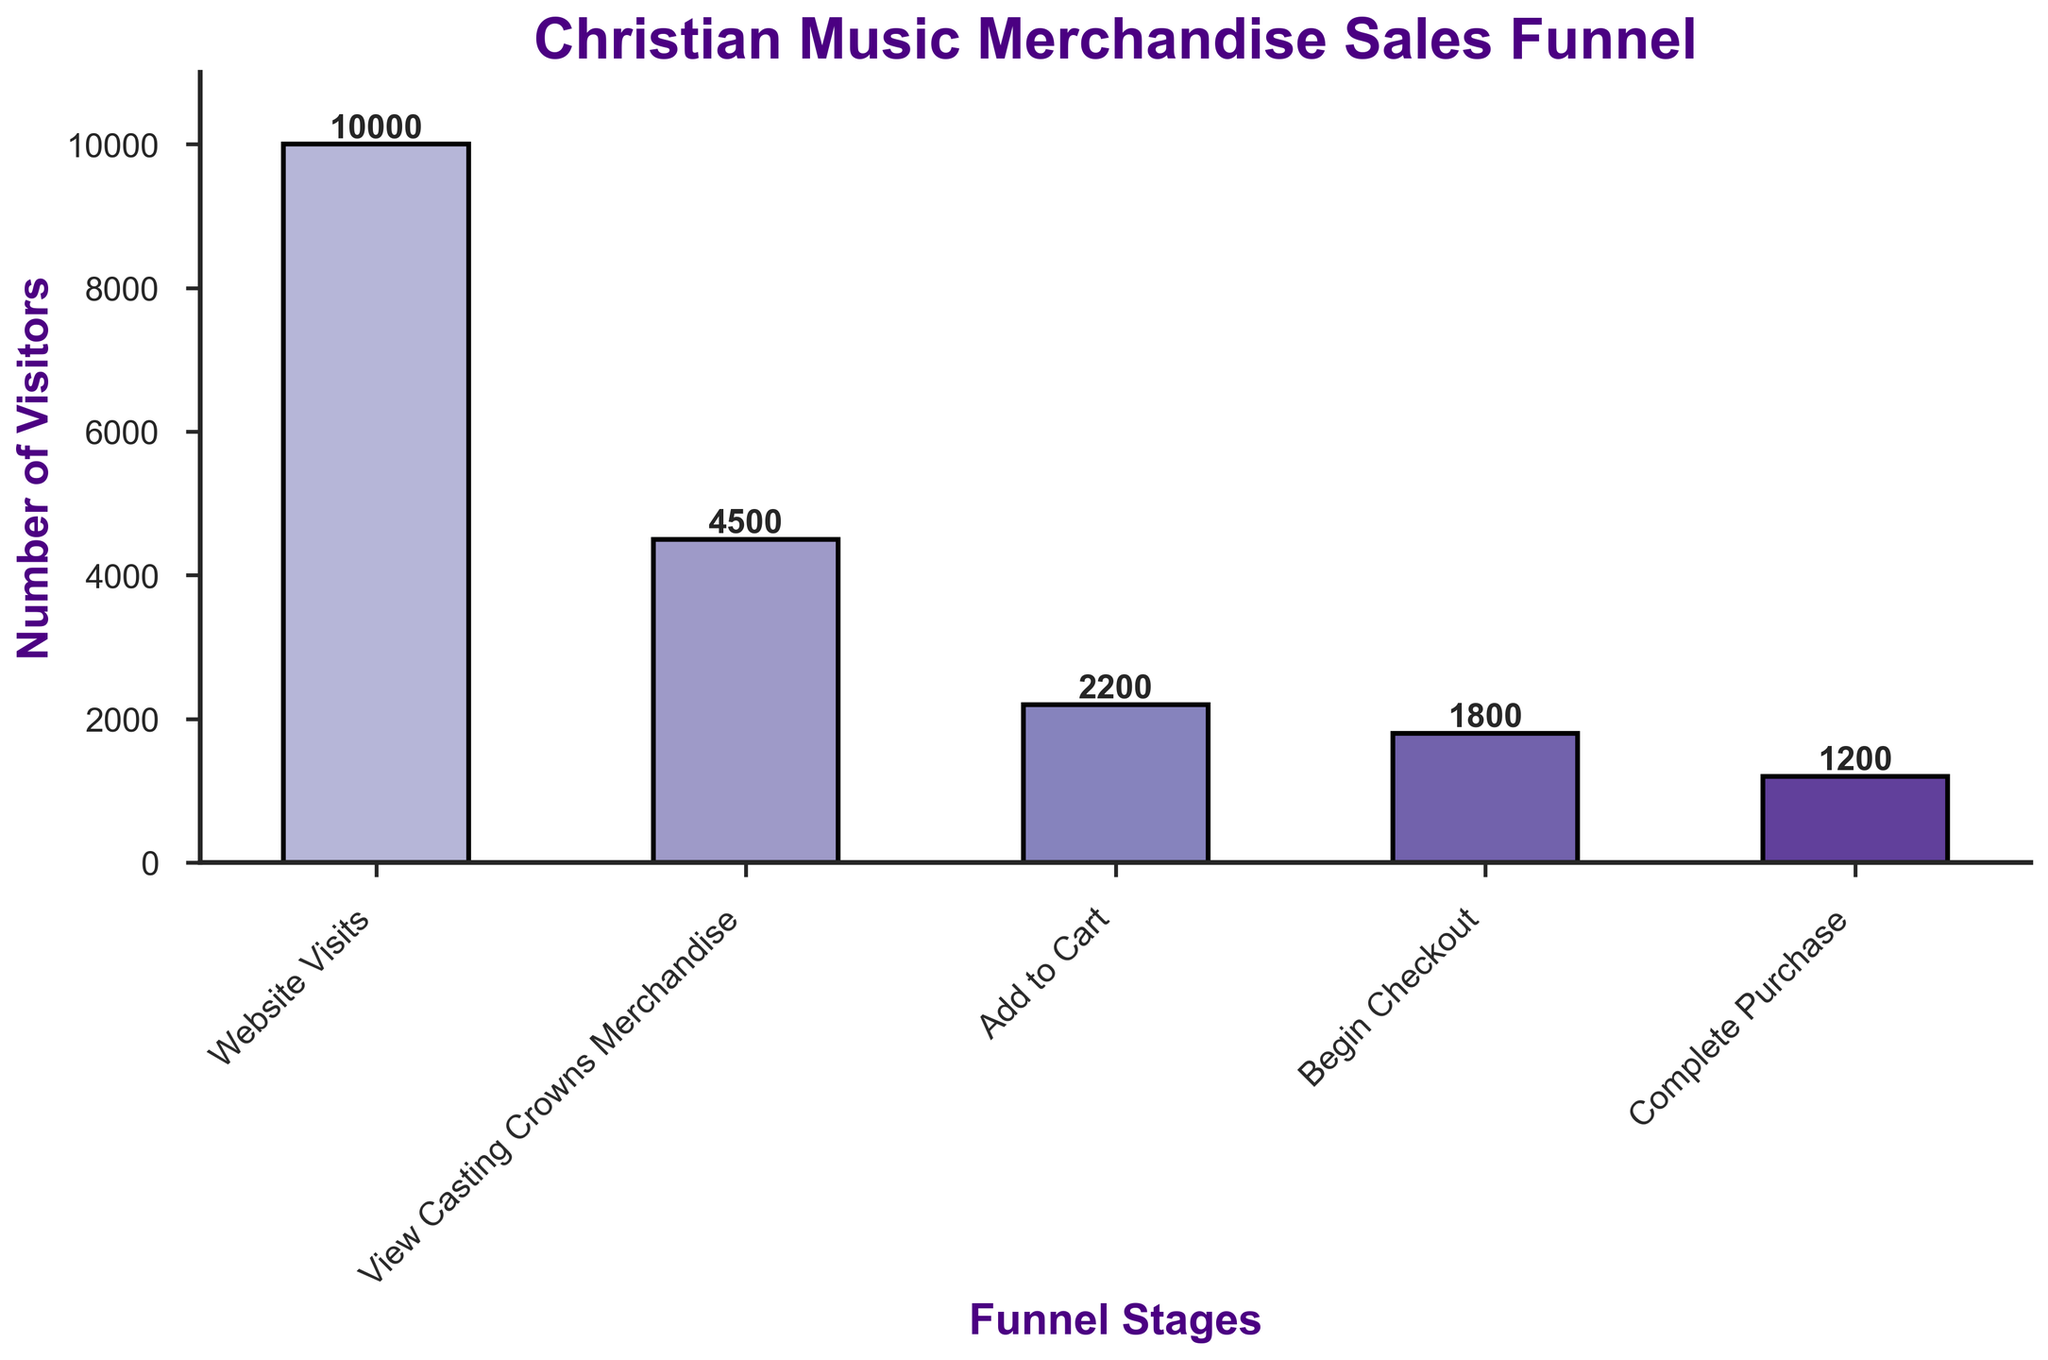what is the title of the chart? The title of the chart is located at the top of the figure and it is usually the main descriptor of the information presented. The title reads "Christian Music Merchandise Sales Funnel".
Answer: Christian Music Merchandise Sales Funnel How many stages are represented in the funnel chart? By counting the distinct bars or labels on the x-axis, we can see there are 5 stages represented in the funnel.
Answer: 5 Which stage has the lowest number of visitors? To find the stage with the lowest number, we compare the heights of the bars. The stage "Complete Purchase" has the smallest height, which corresponds to the lowest number of visitors.
Answer: Complete Purchase What's the number of visitors at the "Begin Checkout" stage? The label above the bar for "Begin Checkout" indicates the number of visitors. The number is 1800.
Answer: 1800 What is the total number of visitors who viewed the Casting Crowns merchandise and also added them to the cart? To get this total, sum the visitors from both stages "View Casting Crowns Merchandise" and "Add to Cart". That's 4500 + 2200 = 6700.
Answer: 6700 Calculate the dropout rate between "Add to Cart" and "Complete Purchase" stages. First, find the difference in visitors between the two stages: 2200 (Add to Cart) - 1200 (Complete Purchase) = 1000. Then, divide by the number of visitors at "Add to Cart": 1000 / 2200 = 0.4545. Finally, convert this to a percentage: 0.4545 * 100 = 45.45%.
Answer: 45.45% Which stage has the second highest number of visitors, and what is that number? Look at the bars' heights and labels. "View Casting Crowns Merchandise" has the second highest number with 4500 visitors.
Answer: View Casting Crowns Merchandise, 4500 How many more visitors viewed the Casting Crowns merchandise than completed the purchase? Subtract the number of visitors who completed the purchase from those who viewed the Casting Crowns merchandise: 4500 - 1200 = 3300.
Answer: 3300 What's the percentage decrease from "Website Visits" to "Complete Purchase"? First, calculate the difference: 10000 (Website Visits) - 1200 (Complete Purchase) = 8800. Then, divide by the initial number of Website Visits: 8800 / 10000 = 0.88. Finally, convert to percentage: 0.88 * 100 = 88%.
Answer: 88% Compare the dropout rate between "View Casting Crowns Merchandise" to "Add to Cart" and "Begin Checkout" to "Complete Purchase". Which dropout rate is higher? Calculate dropout rates: From "View Casting Crowns Merchandise" to "Add to Cart" is (4500 - 2200) / 4500 = 0.5111 or 51.11%. From "Begin Checkout" to "Complete Purchase" is (1800 - 1200) / 1800 = 0.3333 or 33.33%. The dropout rate from "View Casting Crowns Merchandise" to "Add to Cart" is higher.
Answer: View Casting Crowns Merchandise to Add to Cart 